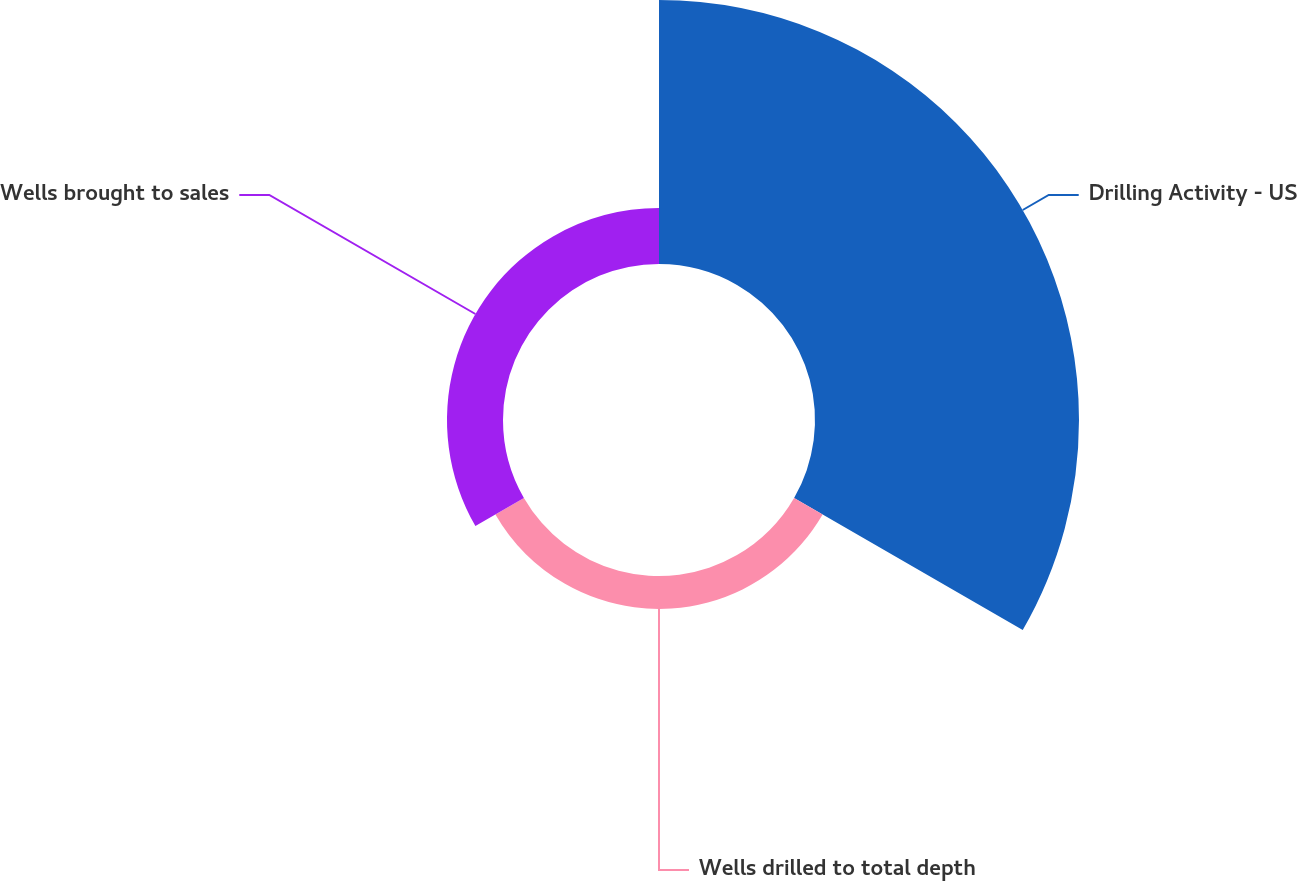Convert chart. <chart><loc_0><loc_0><loc_500><loc_500><pie_chart><fcel>Drilling Activity - US<fcel>Wells drilled to total depth<fcel>Wells brought to sales<nl><fcel>74.81%<fcel>9.32%<fcel>15.87%<nl></chart> 